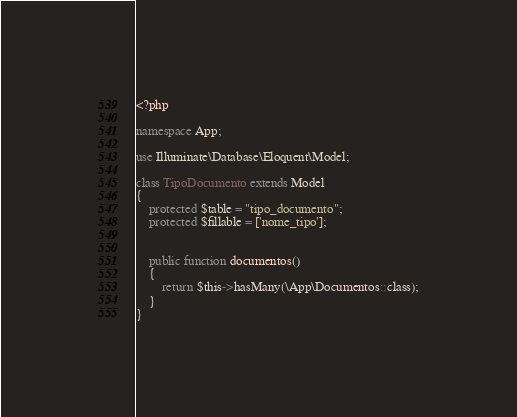<code> <loc_0><loc_0><loc_500><loc_500><_PHP_><?php

namespace App;

use Illuminate\Database\Eloquent\Model;

class TipoDocumento extends Model
{
    protected $table = "tipo_documento";
    protected $fillable = ['nome_tipo'];


    public function documentos()
    {
        return $this->hasMany(\App\Documentos::class);
    }
}
</code> 